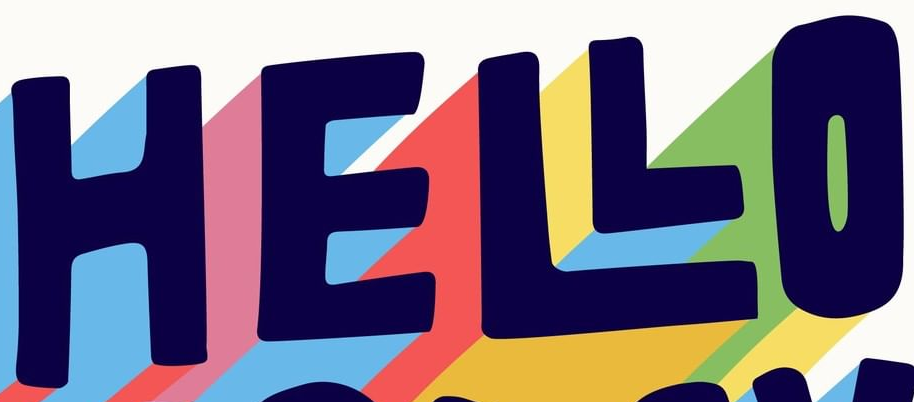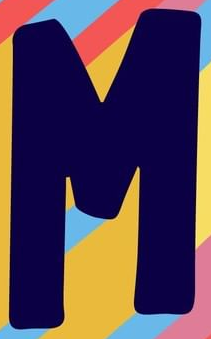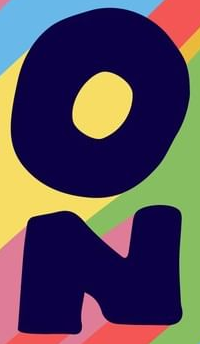What words can you see in these images in sequence, separated by a semicolon? HELLO; M; ON 